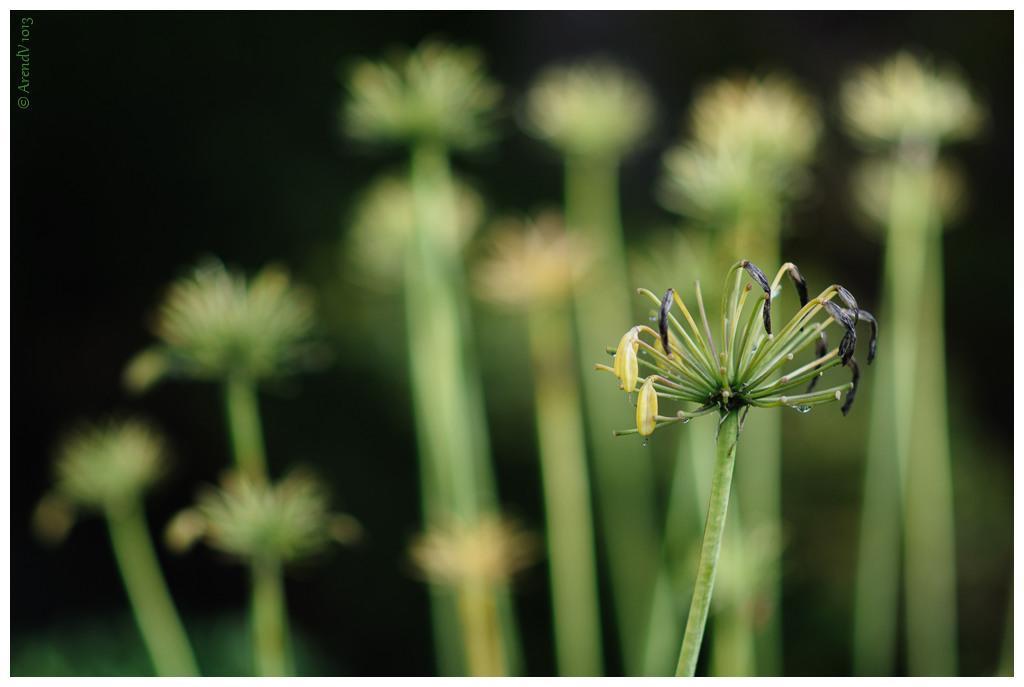In one or two sentences, can you explain what this image depicts? In the picture I can see a flower. In the background I can see flowers. The background of the image is blurred. 